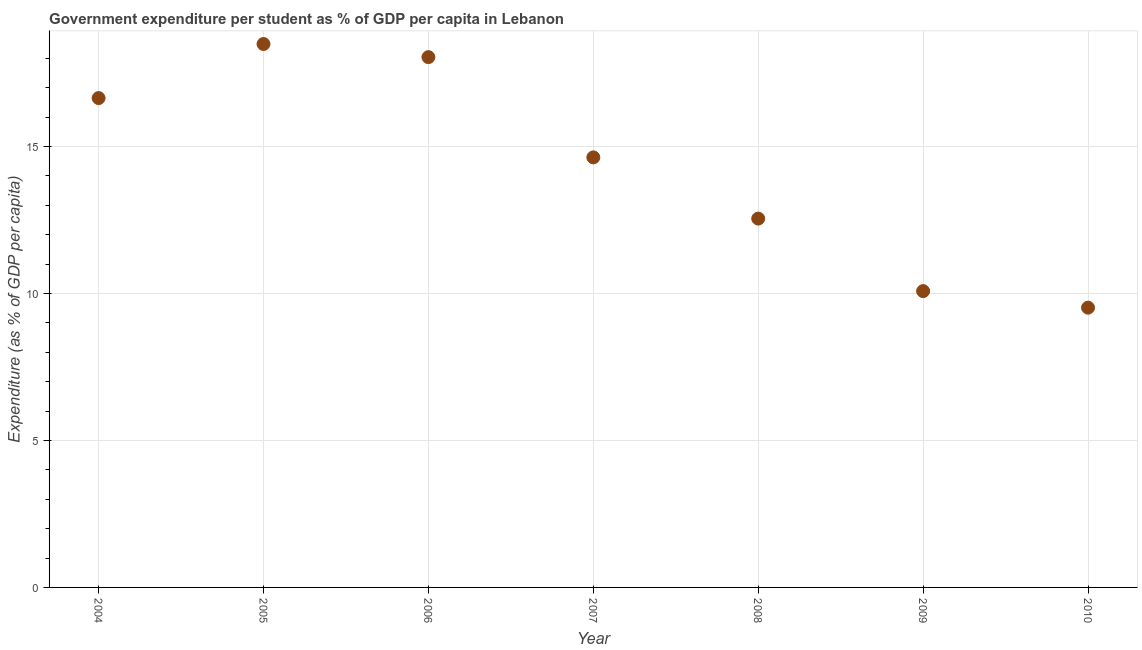What is the government expenditure per student in 2005?
Ensure brevity in your answer.  18.49. Across all years, what is the maximum government expenditure per student?
Ensure brevity in your answer.  18.49. Across all years, what is the minimum government expenditure per student?
Keep it short and to the point. 9.52. In which year was the government expenditure per student maximum?
Ensure brevity in your answer.  2005. In which year was the government expenditure per student minimum?
Provide a short and direct response. 2010. What is the sum of the government expenditure per student?
Your answer should be compact. 99.97. What is the difference between the government expenditure per student in 2006 and 2007?
Give a very brief answer. 3.41. What is the average government expenditure per student per year?
Offer a terse response. 14.28. What is the median government expenditure per student?
Provide a succinct answer. 14.63. Do a majority of the years between 2010 and 2007 (inclusive) have government expenditure per student greater than 1 %?
Your answer should be very brief. Yes. What is the ratio of the government expenditure per student in 2007 to that in 2010?
Offer a very short reply. 1.54. Is the government expenditure per student in 2005 less than that in 2008?
Offer a very short reply. No. What is the difference between the highest and the second highest government expenditure per student?
Your response must be concise. 0.45. Is the sum of the government expenditure per student in 2004 and 2006 greater than the maximum government expenditure per student across all years?
Your response must be concise. Yes. What is the difference between the highest and the lowest government expenditure per student?
Your response must be concise. 8.97. In how many years, is the government expenditure per student greater than the average government expenditure per student taken over all years?
Your response must be concise. 4. What is the difference between two consecutive major ticks on the Y-axis?
Offer a terse response. 5. Does the graph contain any zero values?
Offer a terse response. No. What is the title of the graph?
Your answer should be very brief. Government expenditure per student as % of GDP per capita in Lebanon. What is the label or title of the X-axis?
Your answer should be compact. Year. What is the label or title of the Y-axis?
Provide a succinct answer. Expenditure (as % of GDP per capita). What is the Expenditure (as % of GDP per capita) in 2004?
Make the answer very short. 16.65. What is the Expenditure (as % of GDP per capita) in 2005?
Offer a terse response. 18.49. What is the Expenditure (as % of GDP per capita) in 2006?
Provide a short and direct response. 18.04. What is the Expenditure (as % of GDP per capita) in 2007?
Offer a terse response. 14.63. What is the Expenditure (as % of GDP per capita) in 2008?
Provide a short and direct response. 12.55. What is the Expenditure (as % of GDP per capita) in 2009?
Your response must be concise. 10.08. What is the Expenditure (as % of GDP per capita) in 2010?
Ensure brevity in your answer.  9.52. What is the difference between the Expenditure (as % of GDP per capita) in 2004 and 2005?
Your answer should be compact. -1.84. What is the difference between the Expenditure (as % of GDP per capita) in 2004 and 2006?
Your answer should be very brief. -1.39. What is the difference between the Expenditure (as % of GDP per capita) in 2004 and 2007?
Give a very brief answer. 2.02. What is the difference between the Expenditure (as % of GDP per capita) in 2004 and 2008?
Offer a very short reply. 4.1. What is the difference between the Expenditure (as % of GDP per capita) in 2004 and 2009?
Provide a succinct answer. 6.57. What is the difference between the Expenditure (as % of GDP per capita) in 2004 and 2010?
Your answer should be compact. 7.13. What is the difference between the Expenditure (as % of GDP per capita) in 2005 and 2006?
Your answer should be compact. 0.45. What is the difference between the Expenditure (as % of GDP per capita) in 2005 and 2007?
Your answer should be very brief. 3.86. What is the difference between the Expenditure (as % of GDP per capita) in 2005 and 2008?
Ensure brevity in your answer.  5.94. What is the difference between the Expenditure (as % of GDP per capita) in 2005 and 2009?
Offer a very short reply. 8.41. What is the difference between the Expenditure (as % of GDP per capita) in 2005 and 2010?
Ensure brevity in your answer.  8.97. What is the difference between the Expenditure (as % of GDP per capita) in 2006 and 2007?
Offer a very short reply. 3.41. What is the difference between the Expenditure (as % of GDP per capita) in 2006 and 2008?
Your response must be concise. 5.49. What is the difference between the Expenditure (as % of GDP per capita) in 2006 and 2009?
Offer a terse response. 7.96. What is the difference between the Expenditure (as % of GDP per capita) in 2006 and 2010?
Provide a succinct answer. 8.52. What is the difference between the Expenditure (as % of GDP per capita) in 2007 and 2008?
Make the answer very short. 2.08. What is the difference between the Expenditure (as % of GDP per capita) in 2007 and 2009?
Give a very brief answer. 4.55. What is the difference between the Expenditure (as % of GDP per capita) in 2007 and 2010?
Ensure brevity in your answer.  5.11. What is the difference between the Expenditure (as % of GDP per capita) in 2008 and 2009?
Offer a very short reply. 2.47. What is the difference between the Expenditure (as % of GDP per capita) in 2008 and 2010?
Your answer should be compact. 3.03. What is the difference between the Expenditure (as % of GDP per capita) in 2009 and 2010?
Offer a very short reply. 0.56. What is the ratio of the Expenditure (as % of GDP per capita) in 2004 to that in 2006?
Provide a succinct answer. 0.92. What is the ratio of the Expenditure (as % of GDP per capita) in 2004 to that in 2007?
Provide a short and direct response. 1.14. What is the ratio of the Expenditure (as % of GDP per capita) in 2004 to that in 2008?
Provide a short and direct response. 1.33. What is the ratio of the Expenditure (as % of GDP per capita) in 2004 to that in 2009?
Give a very brief answer. 1.65. What is the ratio of the Expenditure (as % of GDP per capita) in 2004 to that in 2010?
Provide a short and direct response. 1.75. What is the ratio of the Expenditure (as % of GDP per capita) in 2005 to that in 2007?
Ensure brevity in your answer.  1.26. What is the ratio of the Expenditure (as % of GDP per capita) in 2005 to that in 2008?
Ensure brevity in your answer.  1.47. What is the ratio of the Expenditure (as % of GDP per capita) in 2005 to that in 2009?
Your response must be concise. 1.83. What is the ratio of the Expenditure (as % of GDP per capita) in 2005 to that in 2010?
Keep it short and to the point. 1.94. What is the ratio of the Expenditure (as % of GDP per capita) in 2006 to that in 2007?
Offer a terse response. 1.23. What is the ratio of the Expenditure (as % of GDP per capita) in 2006 to that in 2008?
Offer a terse response. 1.44. What is the ratio of the Expenditure (as % of GDP per capita) in 2006 to that in 2009?
Give a very brief answer. 1.79. What is the ratio of the Expenditure (as % of GDP per capita) in 2006 to that in 2010?
Keep it short and to the point. 1.9. What is the ratio of the Expenditure (as % of GDP per capita) in 2007 to that in 2008?
Your answer should be compact. 1.17. What is the ratio of the Expenditure (as % of GDP per capita) in 2007 to that in 2009?
Make the answer very short. 1.45. What is the ratio of the Expenditure (as % of GDP per capita) in 2007 to that in 2010?
Provide a succinct answer. 1.54. What is the ratio of the Expenditure (as % of GDP per capita) in 2008 to that in 2009?
Give a very brief answer. 1.25. What is the ratio of the Expenditure (as % of GDP per capita) in 2008 to that in 2010?
Ensure brevity in your answer.  1.32. What is the ratio of the Expenditure (as % of GDP per capita) in 2009 to that in 2010?
Your response must be concise. 1.06. 